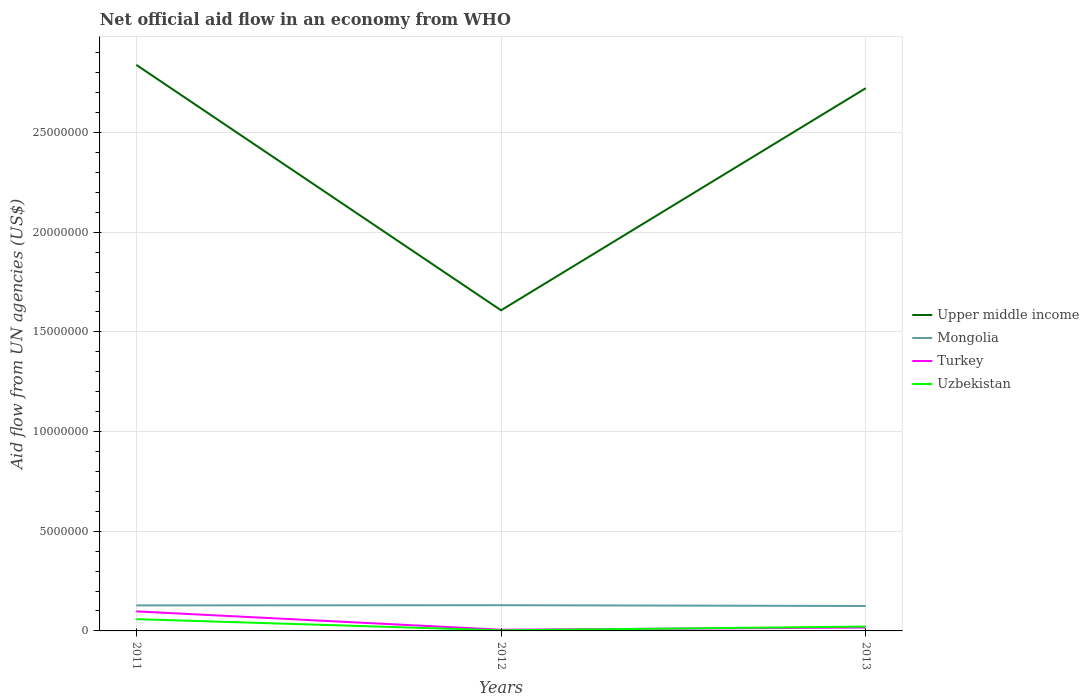How many different coloured lines are there?
Provide a succinct answer. 4. Is the number of lines equal to the number of legend labels?
Offer a very short reply. Yes. Across all years, what is the maximum net official aid flow in Mongolia?
Provide a short and direct response. 1.25e+06. What is the total net official aid flow in Mongolia in the graph?
Provide a succinct answer. -10000. What is the difference between the highest and the second highest net official aid flow in Uzbekistan?
Your response must be concise. 5.60e+05. Is the net official aid flow in Upper middle income strictly greater than the net official aid flow in Turkey over the years?
Provide a short and direct response. No. What is the difference between two consecutive major ticks on the Y-axis?
Ensure brevity in your answer.  5.00e+06. Does the graph contain any zero values?
Your response must be concise. No. Does the graph contain grids?
Your answer should be compact. Yes. Where does the legend appear in the graph?
Give a very brief answer. Center right. How are the legend labels stacked?
Offer a very short reply. Vertical. What is the title of the graph?
Give a very brief answer. Net official aid flow in an economy from WHO. What is the label or title of the Y-axis?
Provide a succinct answer. Aid flow from UN agencies (US$). What is the Aid flow from UN agencies (US$) in Upper middle income in 2011?
Give a very brief answer. 2.84e+07. What is the Aid flow from UN agencies (US$) of Mongolia in 2011?
Make the answer very short. 1.28e+06. What is the Aid flow from UN agencies (US$) of Turkey in 2011?
Your response must be concise. 9.80e+05. What is the Aid flow from UN agencies (US$) in Uzbekistan in 2011?
Your answer should be compact. 5.90e+05. What is the Aid flow from UN agencies (US$) of Upper middle income in 2012?
Make the answer very short. 1.61e+07. What is the Aid flow from UN agencies (US$) in Mongolia in 2012?
Ensure brevity in your answer.  1.29e+06. What is the Aid flow from UN agencies (US$) of Upper middle income in 2013?
Keep it short and to the point. 2.72e+07. What is the Aid flow from UN agencies (US$) in Mongolia in 2013?
Offer a terse response. 1.25e+06. What is the Aid flow from UN agencies (US$) of Uzbekistan in 2013?
Provide a short and direct response. 2.20e+05. Across all years, what is the maximum Aid flow from UN agencies (US$) in Upper middle income?
Offer a very short reply. 2.84e+07. Across all years, what is the maximum Aid flow from UN agencies (US$) in Mongolia?
Provide a short and direct response. 1.29e+06. Across all years, what is the maximum Aid flow from UN agencies (US$) in Turkey?
Offer a very short reply. 9.80e+05. Across all years, what is the maximum Aid flow from UN agencies (US$) of Uzbekistan?
Keep it short and to the point. 5.90e+05. Across all years, what is the minimum Aid flow from UN agencies (US$) of Upper middle income?
Offer a terse response. 1.61e+07. Across all years, what is the minimum Aid flow from UN agencies (US$) in Mongolia?
Make the answer very short. 1.25e+06. Across all years, what is the minimum Aid flow from UN agencies (US$) of Uzbekistan?
Provide a short and direct response. 3.00e+04. What is the total Aid flow from UN agencies (US$) of Upper middle income in the graph?
Your response must be concise. 7.17e+07. What is the total Aid flow from UN agencies (US$) of Mongolia in the graph?
Make the answer very short. 3.82e+06. What is the total Aid flow from UN agencies (US$) in Turkey in the graph?
Make the answer very short. 1.21e+06. What is the total Aid flow from UN agencies (US$) of Uzbekistan in the graph?
Your answer should be compact. 8.40e+05. What is the difference between the Aid flow from UN agencies (US$) in Upper middle income in 2011 and that in 2012?
Provide a short and direct response. 1.23e+07. What is the difference between the Aid flow from UN agencies (US$) of Turkey in 2011 and that in 2012?
Your response must be concise. 9.20e+05. What is the difference between the Aid flow from UN agencies (US$) of Uzbekistan in 2011 and that in 2012?
Offer a terse response. 5.60e+05. What is the difference between the Aid flow from UN agencies (US$) of Upper middle income in 2011 and that in 2013?
Make the answer very short. 1.17e+06. What is the difference between the Aid flow from UN agencies (US$) of Mongolia in 2011 and that in 2013?
Offer a terse response. 3.00e+04. What is the difference between the Aid flow from UN agencies (US$) in Turkey in 2011 and that in 2013?
Your answer should be very brief. 8.10e+05. What is the difference between the Aid flow from UN agencies (US$) in Uzbekistan in 2011 and that in 2013?
Your answer should be compact. 3.70e+05. What is the difference between the Aid flow from UN agencies (US$) of Upper middle income in 2012 and that in 2013?
Make the answer very short. -1.11e+07. What is the difference between the Aid flow from UN agencies (US$) of Mongolia in 2012 and that in 2013?
Keep it short and to the point. 4.00e+04. What is the difference between the Aid flow from UN agencies (US$) of Turkey in 2012 and that in 2013?
Your response must be concise. -1.10e+05. What is the difference between the Aid flow from UN agencies (US$) in Upper middle income in 2011 and the Aid flow from UN agencies (US$) in Mongolia in 2012?
Provide a short and direct response. 2.71e+07. What is the difference between the Aid flow from UN agencies (US$) of Upper middle income in 2011 and the Aid flow from UN agencies (US$) of Turkey in 2012?
Offer a terse response. 2.83e+07. What is the difference between the Aid flow from UN agencies (US$) of Upper middle income in 2011 and the Aid flow from UN agencies (US$) of Uzbekistan in 2012?
Offer a terse response. 2.84e+07. What is the difference between the Aid flow from UN agencies (US$) in Mongolia in 2011 and the Aid flow from UN agencies (US$) in Turkey in 2012?
Keep it short and to the point. 1.22e+06. What is the difference between the Aid flow from UN agencies (US$) of Mongolia in 2011 and the Aid flow from UN agencies (US$) of Uzbekistan in 2012?
Offer a very short reply. 1.25e+06. What is the difference between the Aid flow from UN agencies (US$) in Turkey in 2011 and the Aid flow from UN agencies (US$) in Uzbekistan in 2012?
Offer a terse response. 9.50e+05. What is the difference between the Aid flow from UN agencies (US$) in Upper middle income in 2011 and the Aid flow from UN agencies (US$) in Mongolia in 2013?
Your response must be concise. 2.71e+07. What is the difference between the Aid flow from UN agencies (US$) in Upper middle income in 2011 and the Aid flow from UN agencies (US$) in Turkey in 2013?
Your response must be concise. 2.82e+07. What is the difference between the Aid flow from UN agencies (US$) in Upper middle income in 2011 and the Aid flow from UN agencies (US$) in Uzbekistan in 2013?
Provide a succinct answer. 2.82e+07. What is the difference between the Aid flow from UN agencies (US$) of Mongolia in 2011 and the Aid flow from UN agencies (US$) of Turkey in 2013?
Your answer should be very brief. 1.11e+06. What is the difference between the Aid flow from UN agencies (US$) in Mongolia in 2011 and the Aid flow from UN agencies (US$) in Uzbekistan in 2013?
Give a very brief answer. 1.06e+06. What is the difference between the Aid flow from UN agencies (US$) of Turkey in 2011 and the Aid flow from UN agencies (US$) of Uzbekistan in 2013?
Ensure brevity in your answer.  7.60e+05. What is the difference between the Aid flow from UN agencies (US$) of Upper middle income in 2012 and the Aid flow from UN agencies (US$) of Mongolia in 2013?
Your answer should be compact. 1.48e+07. What is the difference between the Aid flow from UN agencies (US$) of Upper middle income in 2012 and the Aid flow from UN agencies (US$) of Turkey in 2013?
Your answer should be compact. 1.59e+07. What is the difference between the Aid flow from UN agencies (US$) of Upper middle income in 2012 and the Aid flow from UN agencies (US$) of Uzbekistan in 2013?
Offer a very short reply. 1.59e+07. What is the difference between the Aid flow from UN agencies (US$) in Mongolia in 2012 and the Aid flow from UN agencies (US$) in Turkey in 2013?
Your response must be concise. 1.12e+06. What is the difference between the Aid flow from UN agencies (US$) of Mongolia in 2012 and the Aid flow from UN agencies (US$) of Uzbekistan in 2013?
Offer a terse response. 1.07e+06. What is the average Aid flow from UN agencies (US$) of Upper middle income per year?
Provide a succinct answer. 2.39e+07. What is the average Aid flow from UN agencies (US$) in Mongolia per year?
Ensure brevity in your answer.  1.27e+06. What is the average Aid flow from UN agencies (US$) of Turkey per year?
Provide a short and direct response. 4.03e+05. What is the average Aid flow from UN agencies (US$) in Uzbekistan per year?
Provide a succinct answer. 2.80e+05. In the year 2011, what is the difference between the Aid flow from UN agencies (US$) of Upper middle income and Aid flow from UN agencies (US$) of Mongolia?
Make the answer very short. 2.71e+07. In the year 2011, what is the difference between the Aid flow from UN agencies (US$) of Upper middle income and Aid flow from UN agencies (US$) of Turkey?
Ensure brevity in your answer.  2.74e+07. In the year 2011, what is the difference between the Aid flow from UN agencies (US$) of Upper middle income and Aid flow from UN agencies (US$) of Uzbekistan?
Give a very brief answer. 2.78e+07. In the year 2011, what is the difference between the Aid flow from UN agencies (US$) in Mongolia and Aid flow from UN agencies (US$) in Turkey?
Offer a very short reply. 3.00e+05. In the year 2011, what is the difference between the Aid flow from UN agencies (US$) of Mongolia and Aid flow from UN agencies (US$) of Uzbekistan?
Offer a very short reply. 6.90e+05. In the year 2011, what is the difference between the Aid flow from UN agencies (US$) of Turkey and Aid flow from UN agencies (US$) of Uzbekistan?
Make the answer very short. 3.90e+05. In the year 2012, what is the difference between the Aid flow from UN agencies (US$) of Upper middle income and Aid flow from UN agencies (US$) of Mongolia?
Your response must be concise. 1.48e+07. In the year 2012, what is the difference between the Aid flow from UN agencies (US$) of Upper middle income and Aid flow from UN agencies (US$) of Turkey?
Offer a terse response. 1.60e+07. In the year 2012, what is the difference between the Aid flow from UN agencies (US$) in Upper middle income and Aid flow from UN agencies (US$) in Uzbekistan?
Make the answer very short. 1.60e+07. In the year 2012, what is the difference between the Aid flow from UN agencies (US$) in Mongolia and Aid flow from UN agencies (US$) in Turkey?
Provide a short and direct response. 1.23e+06. In the year 2012, what is the difference between the Aid flow from UN agencies (US$) in Mongolia and Aid flow from UN agencies (US$) in Uzbekistan?
Your response must be concise. 1.26e+06. In the year 2012, what is the difference between the Aid flow from UN agencies (US$) of Turkey and Aid flow from UN agencies (US$) of Uzbekistan?
Give a very brief answer. 3.00e+04. In the year 2013, what is the difference between the Aid flow from UN agencies (US$) of Upper middle income and Aid flow from UN agencies (US$) of Mongolia?
Give a very brief answer. 2.60e+07. In the year 2013, what is the difference between the Aid flow from UN agencies (US$) in Upper middle income and Aid flow from UN agencies (US$) in Turkey?
Your answer should be compact. 2.70e+07. In the year 2013, what is the difference between the Aid flow from UN agencies (US$) in Upper middle income and Aid flow from UN agencies (US$) in Uzbekistan?
Keep it short and to the point. 2.70e+07. In the year 2013, what is the difference between the Aid flow from UN agencies (US$) of Mongolia and Aid flow from UN agencies (US$) of Turkey?
Offer a terse response. 1.08e+06. In the year 2013, what is the difference between the Aid flow from UN agencies (US$) of Mongolia and Aid flow from UN agencies (US$) of Uzbekistan?
Keep it short and to the point. 1.03e+06. What is the ratio of the Aid flow from UN agencies (US$) in Upper middle income in 2011 to that in 2012?
Ensure brevity in your answer.  1.77. What is the ratio of the Aid flow from UN agencies (US$) in Mongolia in 2011 to that in 2012?
Offer a very short reply. 0.99. What is the ratio of the Aid flow from UN agencies (US$) in Turkey in 2011 to that in 2012?
Your response must be concise. 16.33. What is the ratio of the Aid flow from UN agencies (US$) of Uzbekistan in 2011 to that in 2012?
Offer a very short reply. 19.67. What is the ratio of the Aid flow from UN agencies (US$) of Upper middle income in 2011 to that in 2013?
Offer a very short reply. 1.04. What is the ratio of the Aid flow from UN agencies (US$) in Turkey in 2011 to that in 2013?
Provide a succinct answer. 5.76. What is the ratio of the Aid flow from UN agencies (US$) of Uzbekistan in 2011 to that in 2013?
Your response must be concise. 2.68. What is the ratio of the Aid flow from UN agencies (US$) in Upper middle income in 2012 to that in 2013?
Your answer should be very brief. 0.59. What is the ratio of the Aid flow from UN agencies (US$) of Mongolia in 2012 to that in 2013?
Offer a terse response. 1.03. What is the ratio of the Aid flow from UN agencies (US$) of Turkey in 2012 to that in 2013?
Keep it short and to the point. 0.35. What is the ratio of the Aid flow from UN agencies (US$) of Uzbekistan in 2012 to that in 2013?
Keep it short and to the point. 0.14. What is the difference between the highest and the second highest Aid flow from UN agencies (US$) of Upper middle income?
Your answer should be very brief. 1.17e+06. What is the difference between the highest and the second highest Aid flow from UN agencies (US$) in Mongolia?
Provide a short and direct response. 10000. What is the difference between the highest and the second highest Aid flow from UN agencies (US$) in Turkey?
Your response must be concise. 8.10e+05. What is the difference between the highest and the second highest Aid flow from UN agencies (US$) in Uzbekistan?
Ensure brevity in your answer.  3.70e+05. What is the difference between the highest and the lowest Aid flow from UN agencies (US$) in Upper middle income?
Offer a very short reply. 1.23e+07. What is the difference between the highest and the lowest Aid flow from UN agencies (US$) in Turkey?
Your answer should be very brief. 9.20e+05. What is the difference between the highest and the lowest Aid flow from UN agencies (US$) in Uzbekistan?
Your response must be concise. 5.60e+05. 